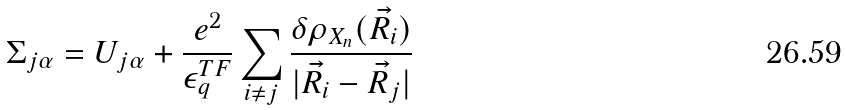<formula> <loc_0><loc_0><loc_500><loc_500>\Sigma _ { j \alpha } = U _ { j \alpha } + \frac { e ^ { 2 } } { \epsilon ^ { T F } _ { q } } \sum _ { i \neq j } \frac { \delta \rho _ { X _ { n } } ( \vec { R } _ { i } ) } { | \vec { R } _ { i } - \vec { R } _ { j } | }</formula> 